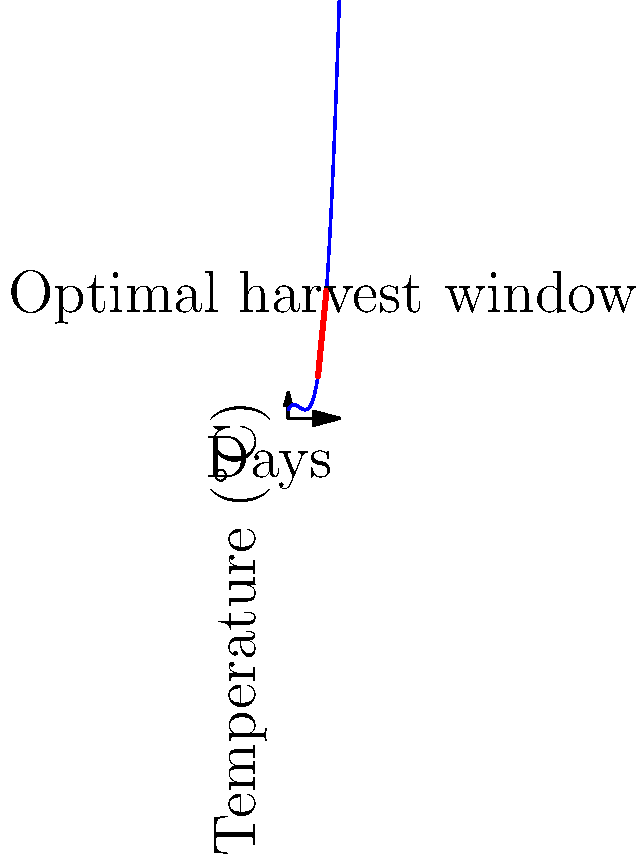Based on the temperature curve shown in the graph, which represents a typical growing season, what is the optimal 10-day window for harvesting to maximize crop yield and quality? To determine the optimal 10-day harvest window, we need to analyze the temperature curve:

1. The curve represents temperature changes over the growing season (60 days).
2. Crops generally have an ideal temperature range for optimal growth and ripening.
3. The peak of the curve indicates the period of highest temperatures.
4. For most crops, the ideal harvest time is just before or at the peak of the temperature curve.
5. Looking at the graph, we can see that the curve reaches its peak around day 40.
6. To maximize yield and quality, we want to harvest when the crop is fully mature but before temperatures start to decline rapidly.
7. A 10-day window centered around the peak would be optimal, allowing for some flexibility in harvesting operations.
8. This window would span from day 35 to day 45, as indicated by the red line on the graph.

Therefore, the optimal 10-day harvest window based on this temperature pattern would be from day 35 to day 45 of the growing season.
Answer: Days 35-45 